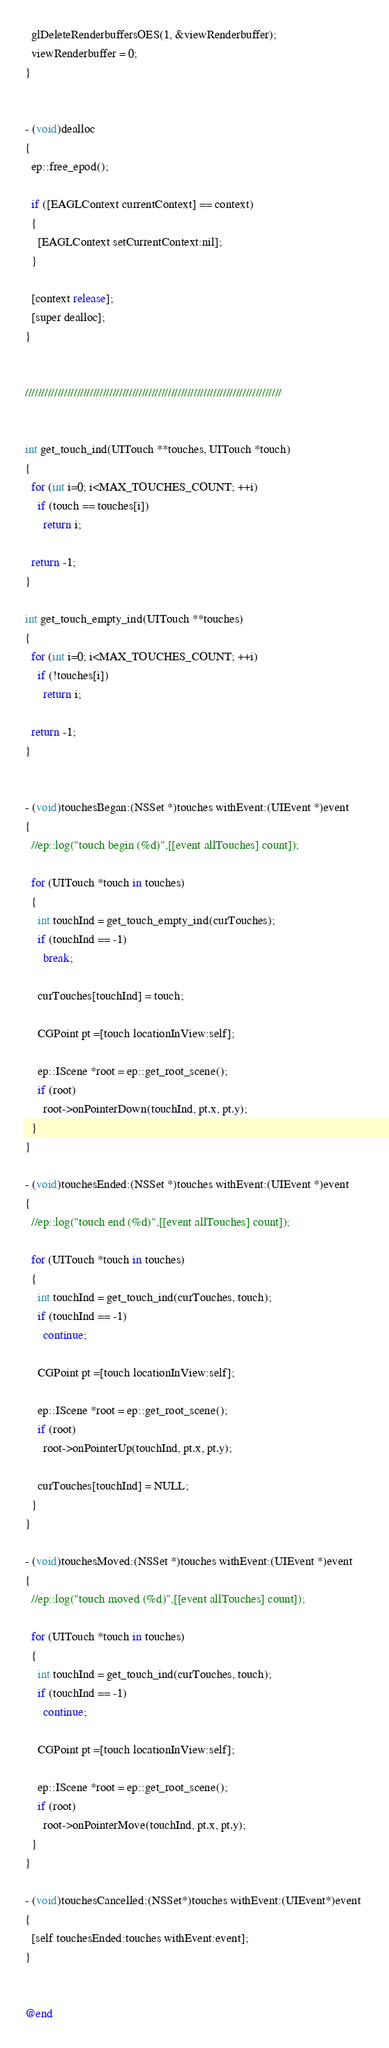<code> <loc_0><loc_0><loc_500><loc_500><_ObjectiveC_>  glDeleteRenderbuffersOES(1, &viewRenderbuffer);
  viewRenderbuffer = 0;
}


- (void)dealloc
{
  ep::free_epod();

  if ([EAGLContext currentContext] == context)
  {
    [EAGLContext setCurrentContext:nil];
  }

  [context release];
  [super dealloc];
}


///////////////////////////////////////////////////////////////////////////////


int get_touch_ind(UITouch **touches, UITouch *touch)
{
  for (int i=0; i<MAX_TOUCHES_COUNT; ++i)
    if (touch == touches[i])
      return i;

  return -1;
}

int get_touch_empty_ind(UITouch **touches)
{
  for (int i=0; i<MAX_TOUCHES_COUNT; ++i)
    if (!touches[i])
      return i;

  return -1;
}


- (void)touchesBegan:(NSSet *)touches withEvent:(UIEvent *)event
{
  //ep::log("touch begin (%d)",[[event allTouches] count]);

  for (UITouch *touch in touches)
  {
    int touchInd = get_touch_empty_ind(curTouches);
    if (touchInd == -1)
      break;

    curTouches[touchInd] = touch;

    CGPoint pt =[touch locationInView:self];

    ep::IScene *root = ep::get_root_scene();
    if (root)
      root->onPointerDown(touchInd, pt.x, pt.y);
  }
}

- (void)touchesEnded:(NSSet *)touches withEvent:(UIEvent *)event
{
  //ep::log("touch end (%d)",[[event allTouches] count]);

  for (UITouch *touch in touches)
  {
    int touchInd = get_touch_ind(curTouches, touch);
    if (touchInd == -1)
      continue;

    CGPoint pt =[touch locationInView:self];

    ep::IScene *root = ep::get_root_scene();
    if (root)
      root->onPointerUp(touchInd, pt.x, pt.y);

    curTouches[touchInd] = NULL;
  }
}

- (void)touchesMoved:(NSSet *)touches withEvent:(UIEvent *)event
{
  //ep::log("touch moved (%d)",[[event allTouches] count]);

  for (UITouch *touch in touches)
  {
    int touchInd = get_touch_ind(curTouches, touch);
    if (touchInd == -1)
      continue;

    CGPoint pt =[touch locationInView:self];

    ep::IScene *root = ep::get_root_scene();
    if (root)
      root->onPointerMove(touchInd, pt.x, pt.y);
  }
}

- (void)touchesCancelled:(NSSet*)touches withEvent:(UIEvent*)event 
{
  [self touchesEnded:touches withEvent:event];
}


@end
</code> 